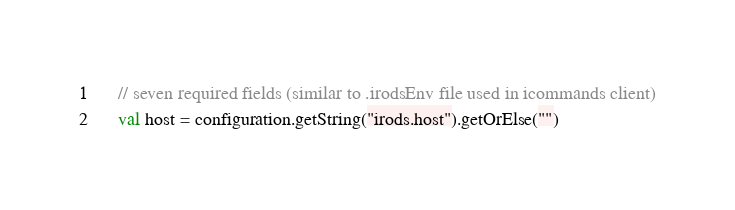Convert code to text. <code><loc_0><loc_0><loc_500><loc_500><_Scala_>	// seven required fields (similar to .irodsEnv file used in icommands client)
	val host = configuration.getString("irods.host").getOrElse("")</code> 